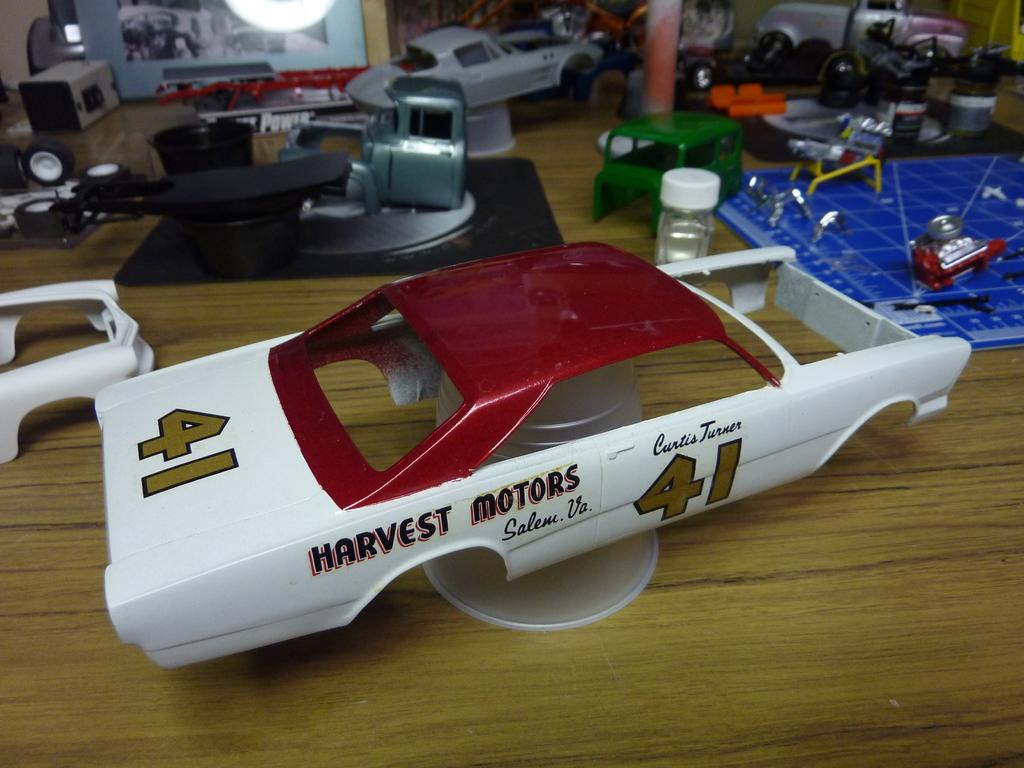What objects are present in the image? There are toys in the image. What type of surface are the toys placed on? The toys are on a wooden surface. What type of industry is depicted in the image? There is no industry depicted in the image; it features toys on a wooden surface. Can you point to the cannon in the image? There is no cannon present in the image. 